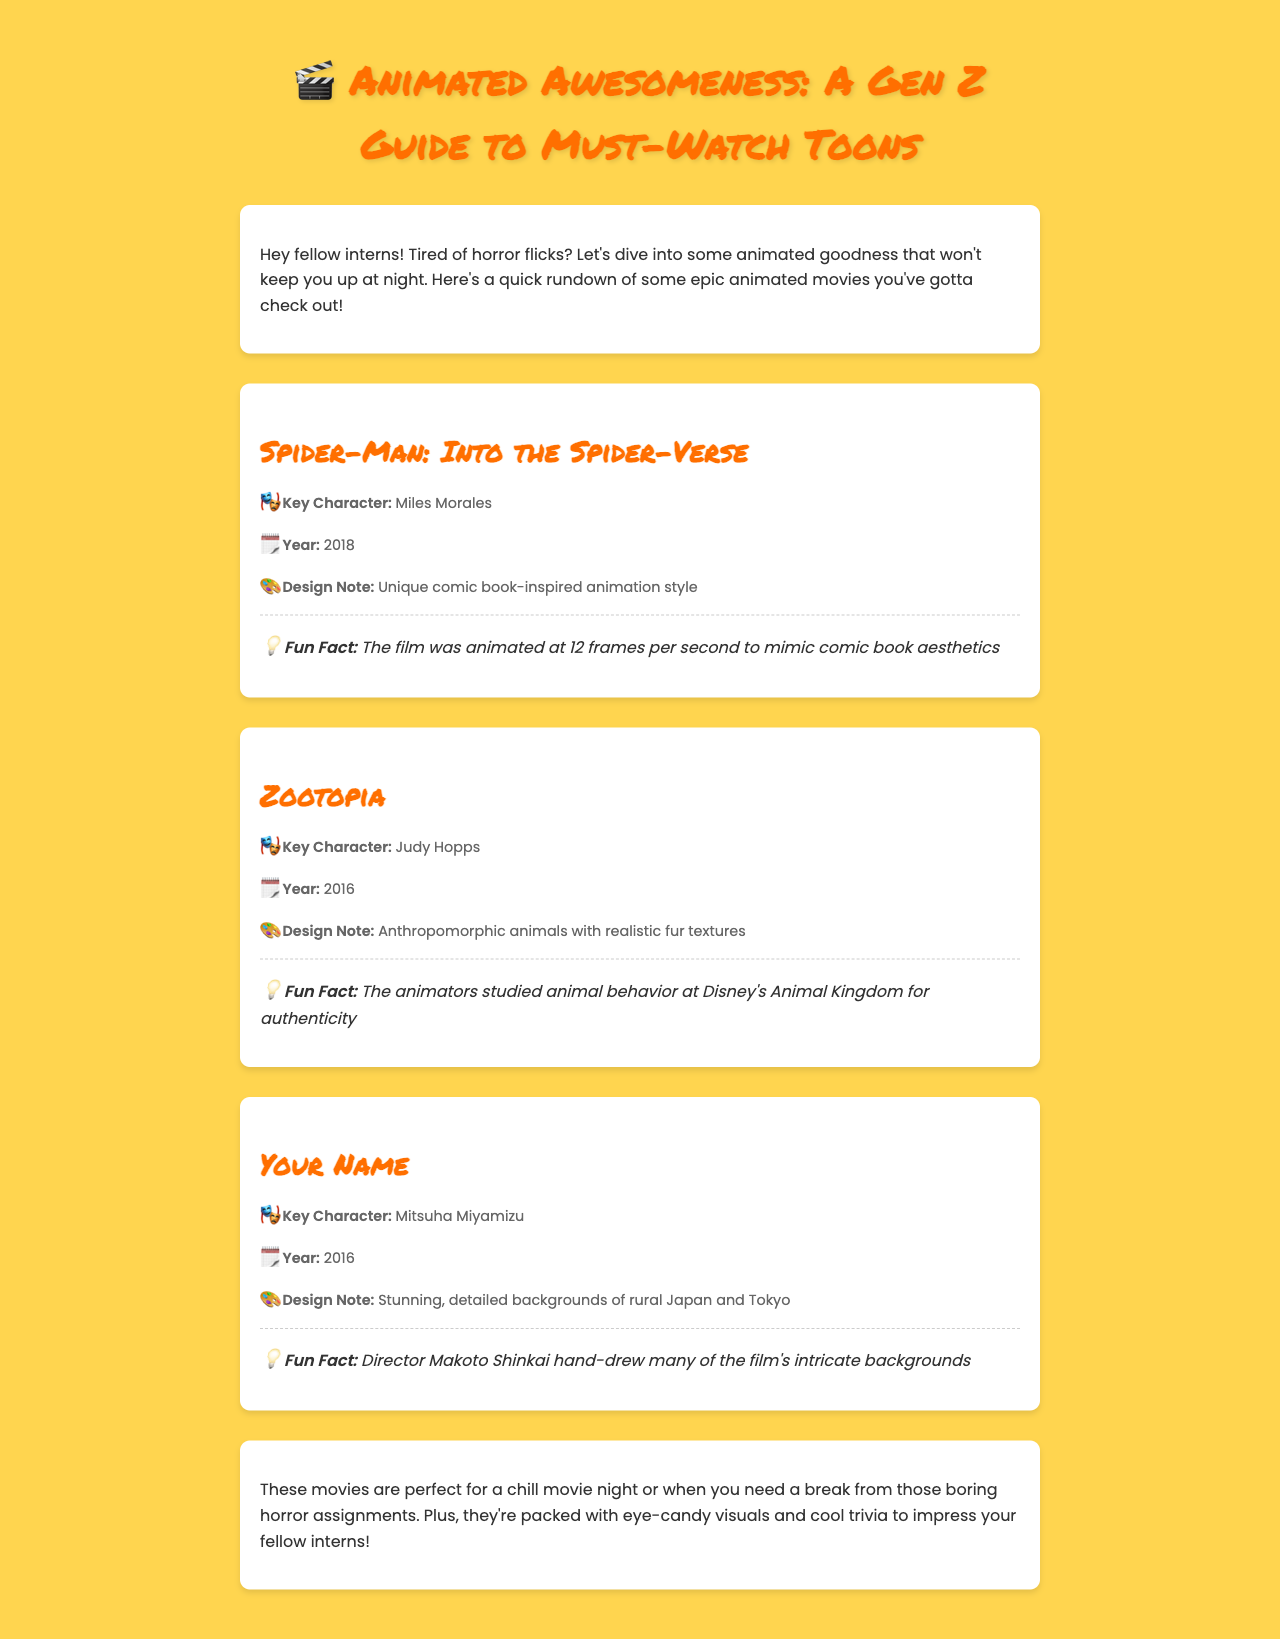What is the title of the first movie listed? The first movie listed in the document is "Spider-Man: Into the Spider-Verse."
Answer: Spider-Man: Into the Spider-Verse Who is the key character in Zootopia? The key character in Zootopia is Judy Hopps.
Answer: Judy Hopps What year was Your Name released? Your Name was released in the year 2016 according to the document.
Answer: 2016 What unique design feature is noted for Spider-Man: Into the Spider-Verse? The document mentions a unique comic book-inspired animation style for Spider-Man: Into the Spider-Verse.
Answer: Unique comic book-inspired animation style Which animator's work was hand-drawn for Your Name? The director Makoto Shinkai hand-drew many of the film's intricate backgrounds in Your Name.
Answer: Makoto Shinkai What type of animation was used in Spider-Man: Into the Spider-Verse? The film is noted for its unique comic book-inspired animation style described in the document.
Answer: Comic book-inspired animation style What specific research did Zootopia animators conduct? The animators studied animal behavior at Disney's Animal Kingdom for authenticity in Zootopia.
Answer: Studied animal behavior What is the main theme of the document? The main theme of the document is a guide to must-watch animated movies for a Gen Z audience.
Answer: Must-watch animated movies 